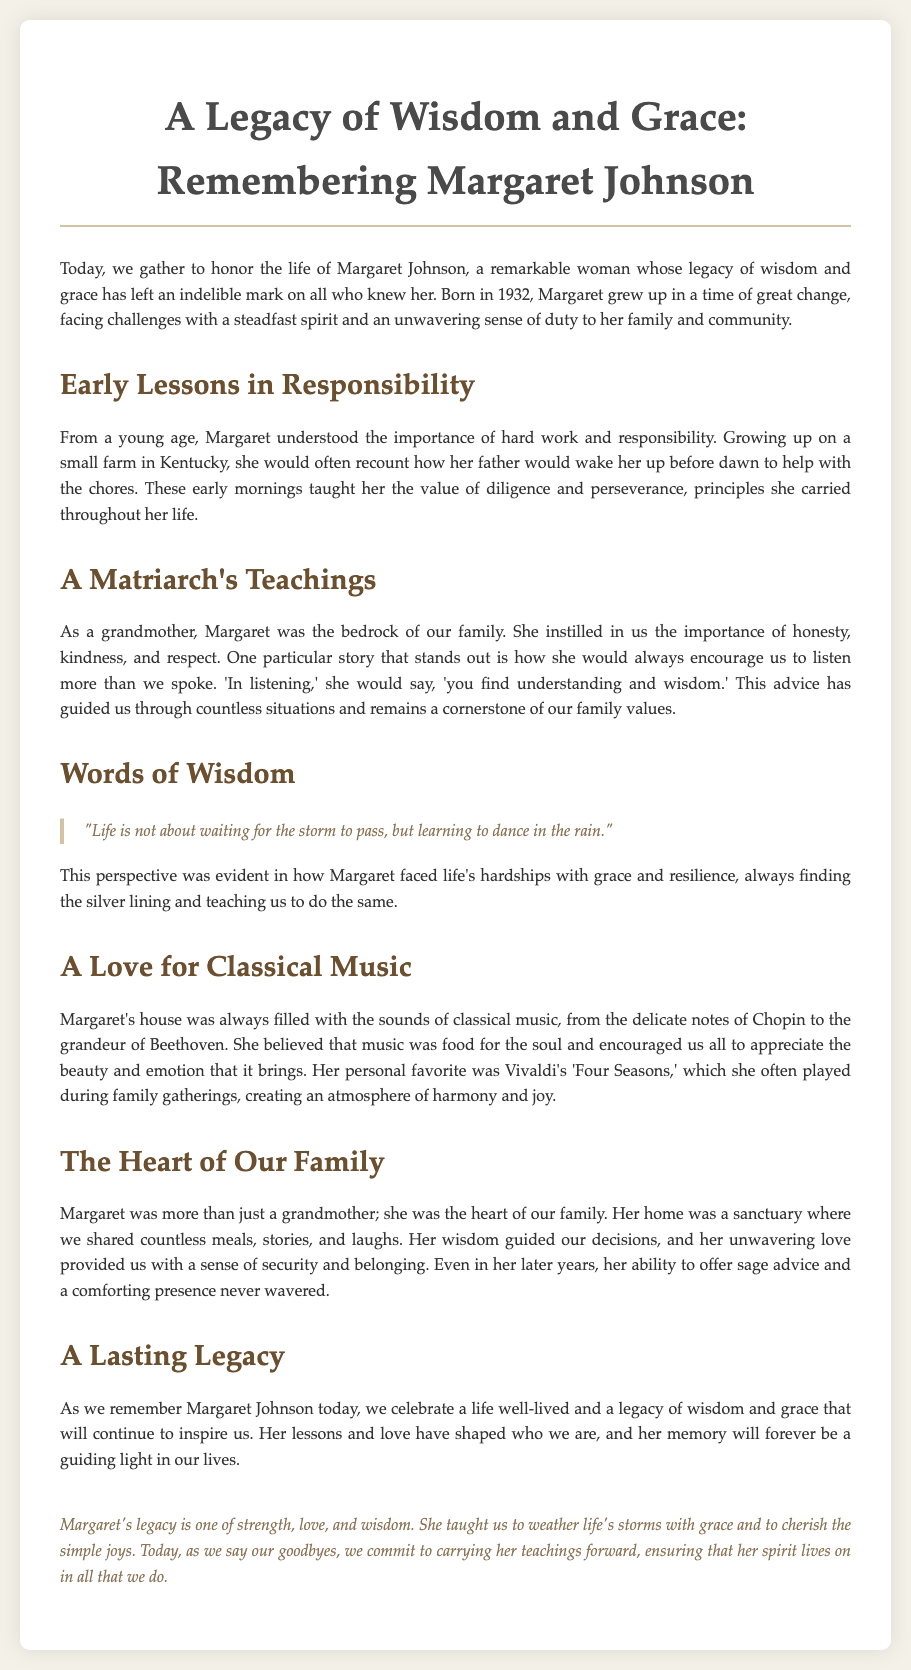What year was Margaret Johnson born? Margaret Johnson was born in 1932, as mentioned in the document.
Answer: 1932 What is one of the key values Margaret instilled in her family? The document highlights honesty, kindness, and respect as key values imparted by Margaret.
Answer: Honesty Which classical composer was mentioned as a favorite of Margaret? The document notes Vivaldi as her personal favorite composer.
Answer: Vivaldi What life lesson did Margaret emphasize regarding listening? Margaret advised that in listening, one finds understanding and wisdom, which is a lesson highlighted in the document.
Answer: Understanding and wisdom How did Margaret's upbringing influence her values? The document explains that growing up on a small farm taught her the value of diligence and perseverance.
Answer: Diligence and perseverance What type of music filled Margaret's home? The document states that classical music filled her home, creating a particular atmosphere.
Answer: Classical music What does the document suggest about Margaret's role in the family? The document positions Margaret as the heart of the family, guiding decisions and providing love.
Answer: Heart of the family What mentality did Margaret encourage when facing difficulties? According to the document, Margaret believed in learning to dance in the rain, which reflects her positive outlook.
Answer: Dance in the rain 